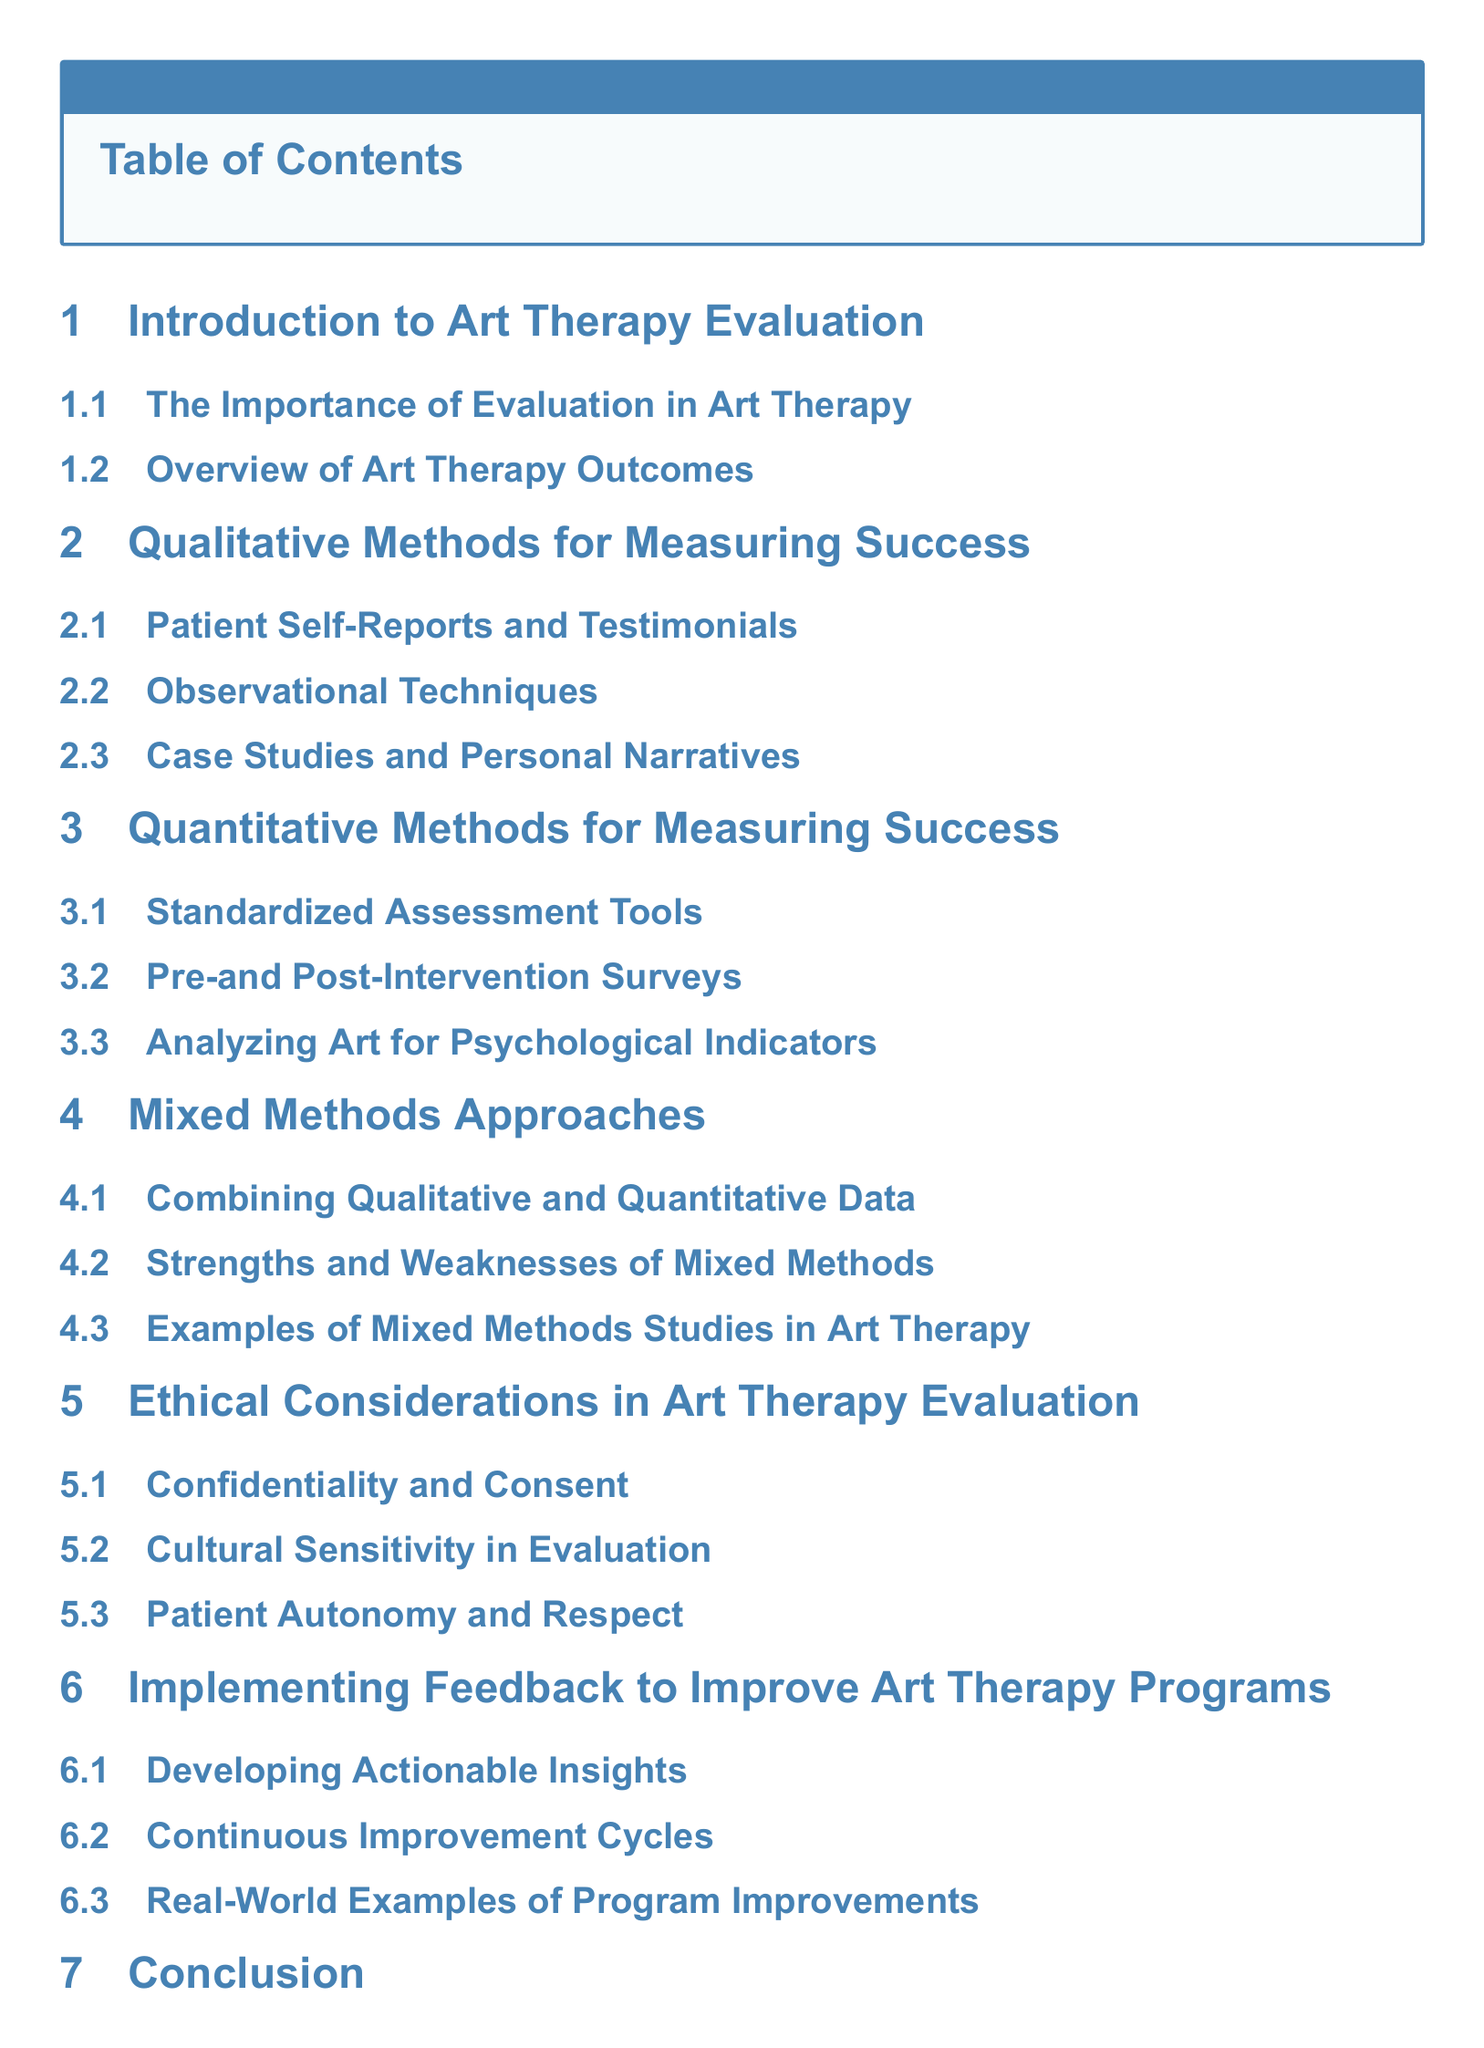What is the first section of the document? The first section is titled "Introduction to Art Therapy Evaluation."
Answer: Introduction to Art Therapy Evaluation How many subsections are under "Quantitative Methods for Measuring Success"? There are three subsections listed under this section.
Answer: 3 What is one qualitative method mentioned for measuring success? "Patient Self-Reports and Testimonials" is one of the qualitative methods mentioned.
Answer: Patient Self-Reports and Testimonials What is a key focus of the section on "Ethical Considerations in Art Therapy Evaluation"? The focus is on ensuring ethical standards such as confidentiality and consent.
Answer: Confidentiality and Consent Which section discusses the combination of qualitative and quantitative data? The section titled "Mixed Methods Approaches" discusses this combination.
Answer: Mixed Methods Approaches 